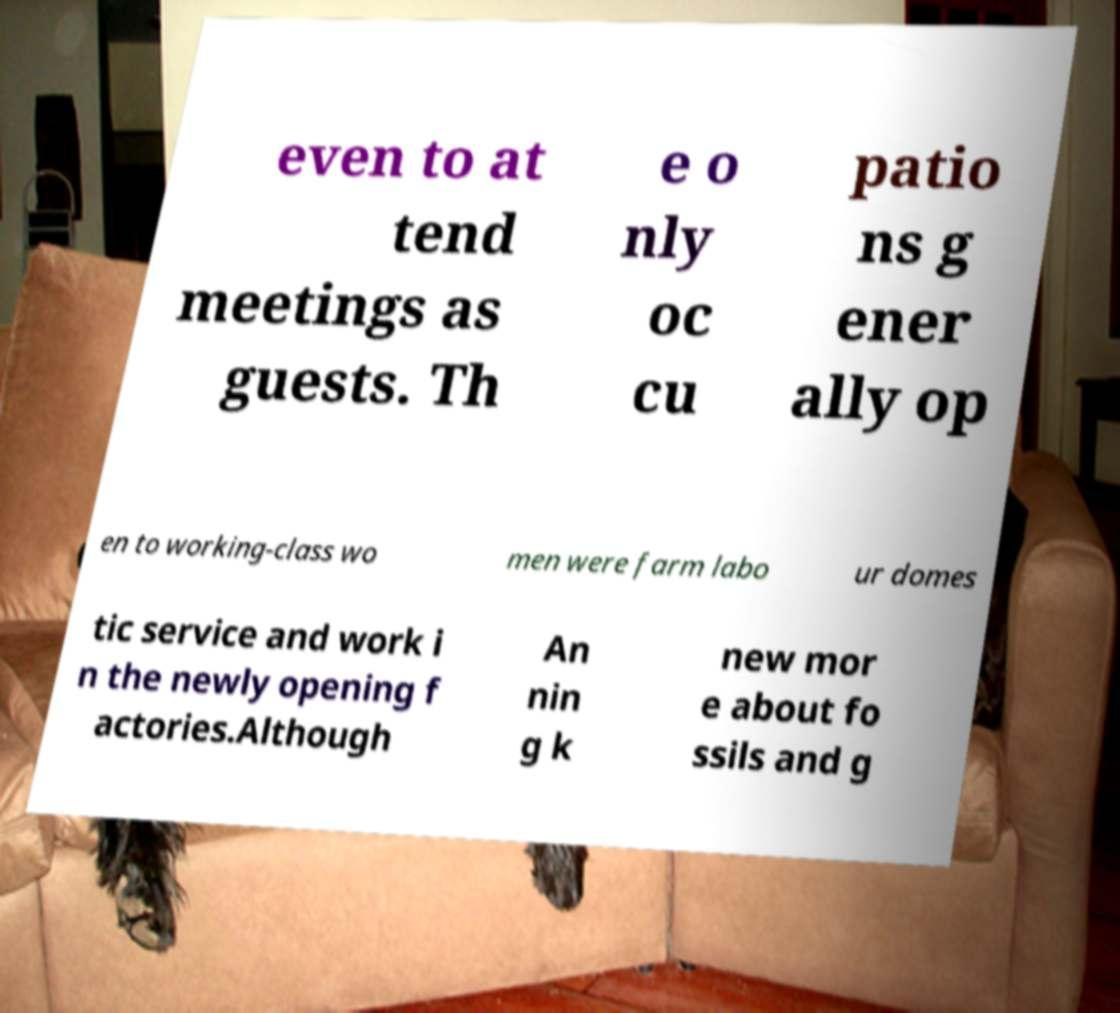For documentation purposes, I need the text within this image transcribed. Could you provide that? even to at tend meetings as guests. Th e o nly oc cu patio ns g ener ally op en to working-class wo men were farm labo ur domes tic service and work i n the newly opening f actories.Although An nin g k new mor e about fo ssils and g 